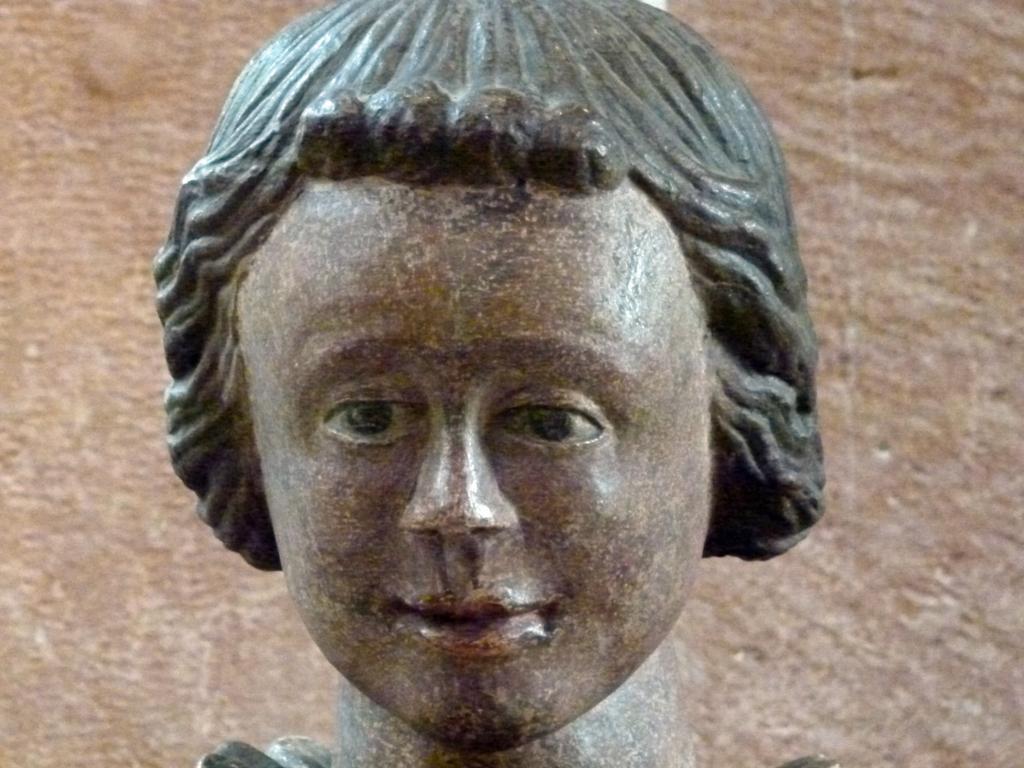Describe this image in one or two sentences. In this picture I can observe sculpture. It is a human head. The background is in brown color. 